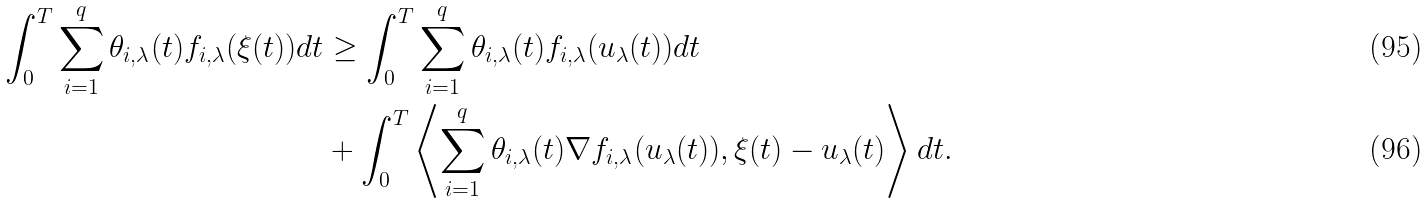<formula> <loc_0><loc_0><loc_500><loc_500>\int _ { 0 } ^ { T } \sum _ { i = 1 } ^ { q } \theta _ { i , \lambda } ( t ) f _ { i , \lambda } ( \xi ( t ) ) d t & \geq \int _ { 0 } ^ { T } \sum _ { i = 1 } ^ { q } \theta _ { i , \lambda } ( t ) f _ { i , \lambda } ( u _ { \lambda } ( t ) ) d t \\ & + \int _ { 0 } ^ { T } \left \langle \sum _ { i = 1 } ^ { q } \theta _ { i , \lambda } ( t ) \nabla f _ { i , \lambda } ( u _ { \lambda } ( t ) ) , \xi ( t ) - u _ { \lambda } ( t ) \right \rangle d t .</formula> 